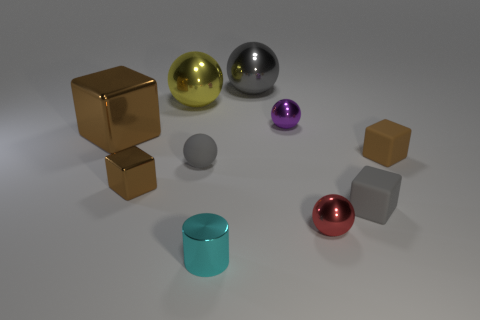There is a tiny gray thing that is the same shape as the yellow object; what is its material?
Provide a succinct answer. Rubber. What number of cubes are right of the metal ball that is left of the tiny cyan object?
Your answer should be compact. 2. Are there any other things that are the same color as the big metal block?
Your answer should be compact. Yes. How many things are brown metal blocks or brown objects that are to the left of the gray matte block?
Provide a succinct answer. 2. What material is the small brown thing in front of the brown block right of the large thing that is behind the yellow ball?
Your response must be concise. Metal. There is a red thing that is the same material as the small cylinder; what size is it?
Provide a short and direct response. Small. The small cube that is on the left side of the gray sphere behind the small matte ball is what color?
Provide a succinct answer. Brown. What number of big brown objects have the same material as the yellow object?
Your response must be concise. 1. How many shiny objects are either tiny yellow cylinders or tiny red objects?
Offer a very short reply. 1. There is a gray ball that is the same size as the cylinder; what material is it?
Provide a short and direct response. Rubber. 